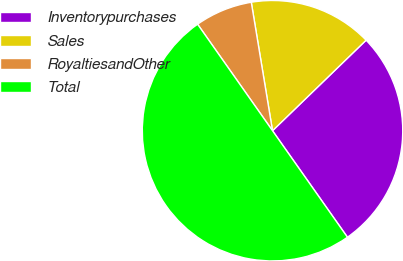Convert chart. <chart><loc_0><loc_0><loc_500><loc_500><pie_chart><fcel>Inventorypurchases<fcel>Sales<fcel>RoyaltiesandOther<fcel>Total<nl><fcel>27.48%<fcel>15.37%<fcel>7.15%<fcel>50.0%<nl></chart> 